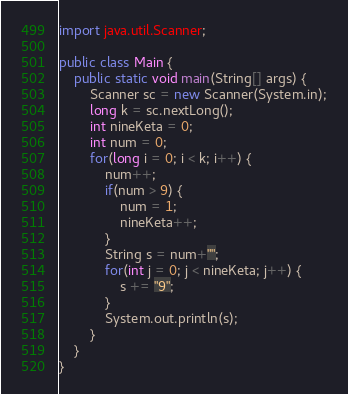<code> <loc_0><loc_0><loc_500><loc_500><_Java_>import java.util.Scanner;

public class Main {
    public static void main(String[] args) {
        Scanner sc = new Scanner(System.in);
        long k = sc.nextLong();
        int nineKeta = 0;
        int num = 0;
        for(long i = 0; i < k; i++) {
            num++;
            if(num > 9) {
                num = 1;
                nineKeta++;
            }
            String s = num+"";
            for(int j = 0; j < nineKeta; j++) {
                s += "9";
            }
            System.out.println(s);
        }
    }
}</code> 